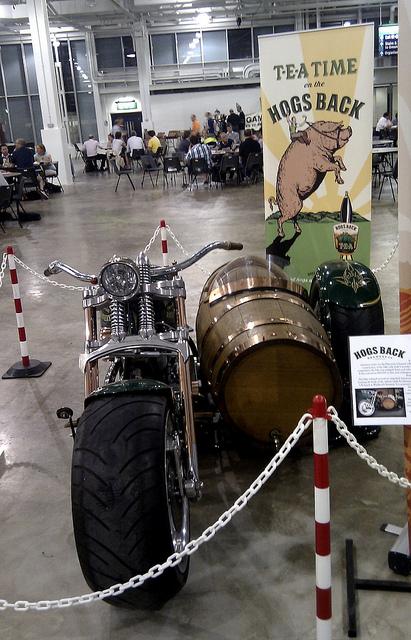Where are the people located?
Answer briefly. Background. Is there a chain here?
Write a very short answer. Yes. What is on the big sign?
Answer briefly. Hog. 